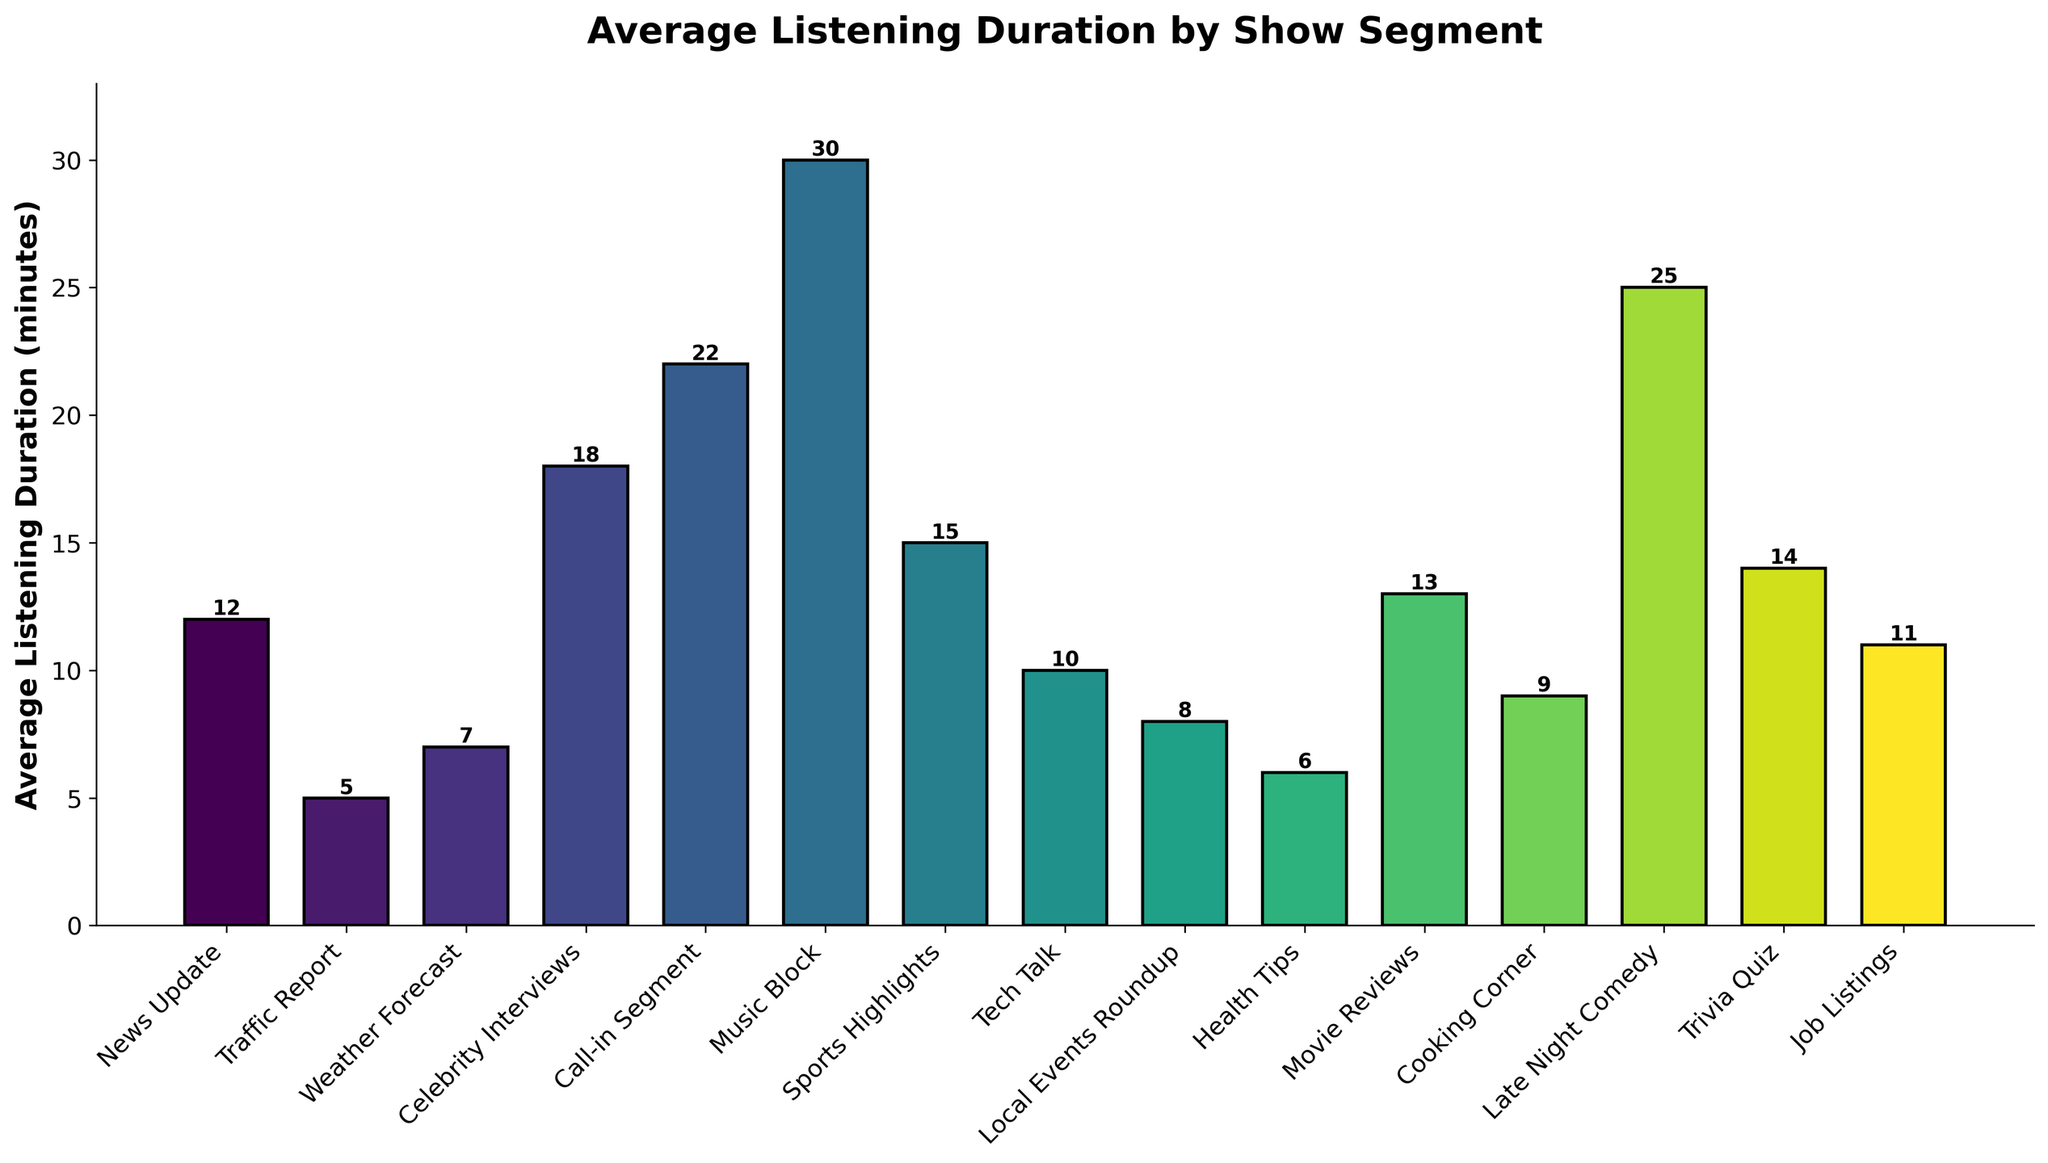What's the longest average listening duration? According to the figure, the "Music Block" segment has the longest average listening duration, visualized by the tallest bar, which corresponds to 30 minutes.
Answer: Music Block (30 minutes) Which segment has a higher average listening duration, "Movie Reviews" or "Health Tips"? Referencing the figure, the "Movie Reviews" segment has a bar height corresponding to 13 minutes, whereas the "Health Tips" segment has a bar height of 6 minutes. Therefore, "Movie Reviews" has a higher average listening duration.
Answer: Movie Reviews What's the combined average listening duration for "Traffic Report" and "Weather Forecast"? From the figure, "Traffic Report" has an average listening duration of 5 minutes, and "Weather Forecast" has 7 minutes. Their combined duration is 5 + 7 = 12 minutes.
Answer: 12 minutes Which segment is listened to less on average, "Cooking Corner" or "Tech Talk"? The bar representing the "Cooking Corner" segment has a height corresponding to 9 minutes, while the "Tech Talk" segment has a height of 10 minutes. Thus, "Cooking Corner" is listened to less on average.
Answer: Cooking Corner Are there any segments with the same average listening duration? Examining the length of the bars, there are no two segments with exactly the same height, meaning there are no segments with identical average listening durations in the figure.
Answer: No What's the difference in average listening duration between "Late Night Comedy" and "Celebrity Interviews"? The bar representing "Late Night Comedy" is 25 minutes tall, while the bar for "Celebrity Interviews" is 18 minutes tall. The difference between their average listening durations is 25 - 18 = 7 minutes.
Answer: 7 minutes How many segments have an average listening duration higher than 15 minutes? Looking at the lengths of the bars, the segments "Celebrity Interviews", "Call-in Segment", "Music Block", "Late Night Comedy", and "Trivia Quiz" have average durations higher than 15 minutes. Thus, 5 segments meet this criterion.
Answer: 5 segments Which segment has the shortest average listening duration? According to the figure, the "Traffic Report" segment has the shortest average listening duration, depicted by the shortest bar, which corresponds to 5 minutes.
Answer: Traffic Report 